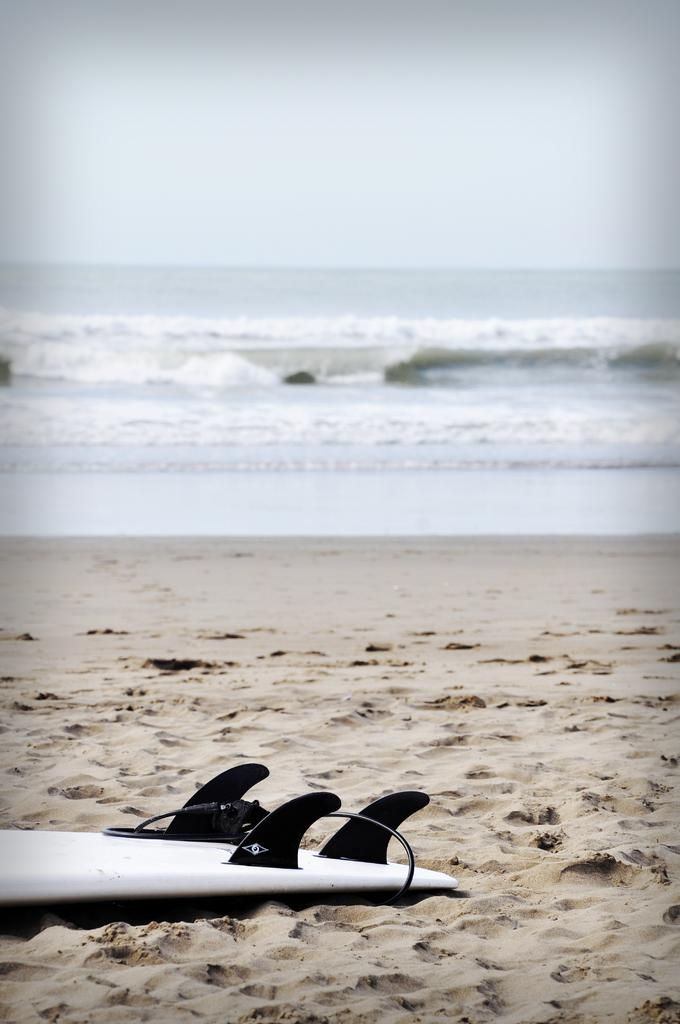Where was the image taken? The image was taken at the sea shore. What type of terrain is visible at the bottom of the image? There is sand at the bottom of the image. What object can be seen on the sand? There is a board on the sand. What large body of water is visible in the image? There is an ocean visible in the image. What part of the natural environment is visible in the image? The sky is visible in the image. What type of winter clothing is worn by the army in the image? There is no army or winter clothing present in the image. What sound does the horn make in the image? There is no horn present in the image. 